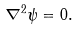Convert formula to latex. <formula><loc_0><loc_0><loc_500><loc_500>\nabla ^ { 2 } \psi = 0 .</formula> 